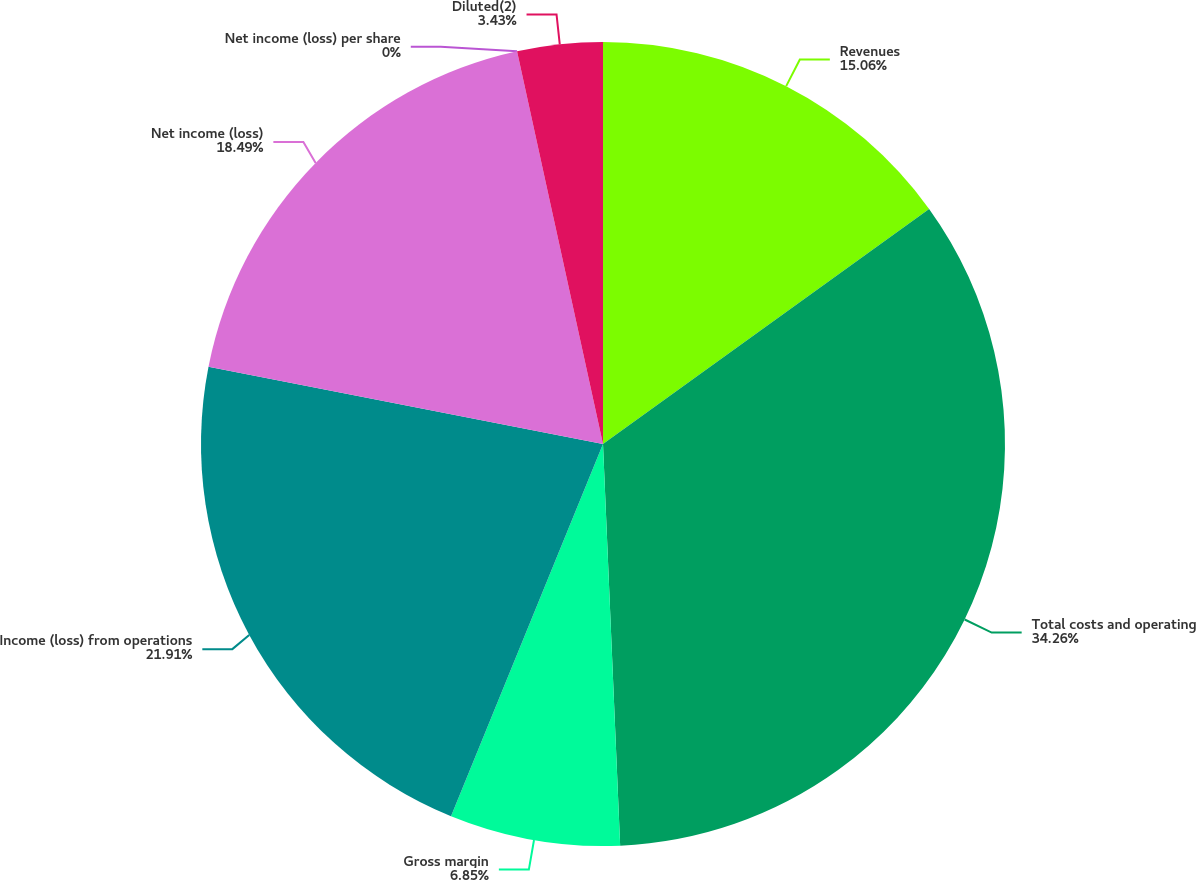<chart> <loc_0><loc_0><loc_500><loc_500><pie_chart><fcel>Revenues<fcel>Total costs and operating<fcel>Gross margin<fcel>Income (loss) from operations<fcel>Net income (loss)<fcel>Net income (loss) per share<fcel>Diluted(2)<nl><fcel>15.06%<fcel>34.26%<fcel>6.85%<fcel>21.91%<fcel>18.49%<fcel>0.0%<fcel>3.43%<nl></chart> 